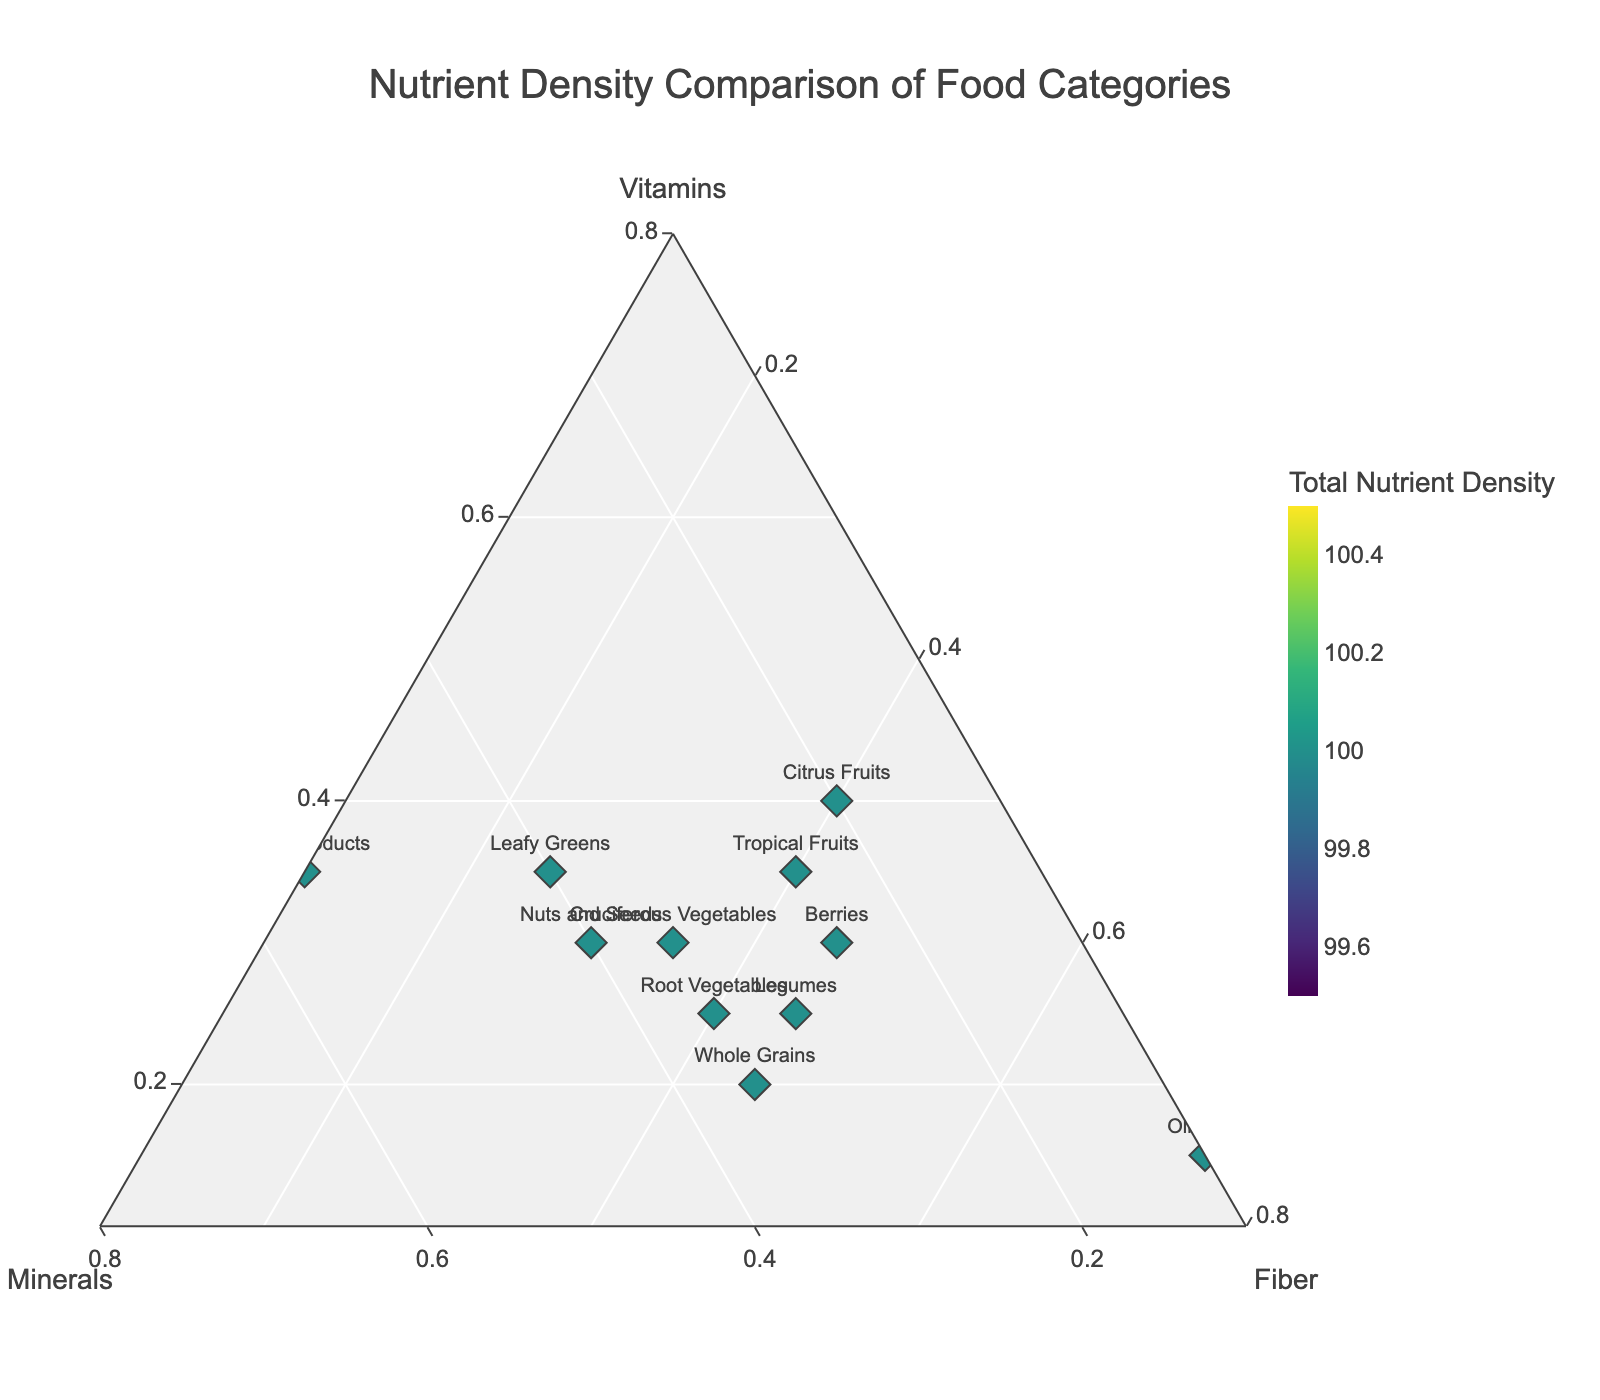How many food categories are shown in the plot? The title states the figure is a comparison of food categories, and each marker corresponds to a food category. Count the unique labels.
Answer: 14 Which food category has the highest total nutrient density? Look for the marker with the darkest color in the color scale indicating the highest value for "Total Nutrient Density".
Answer: Dairy Products What proportion of vitamins does Lean Meats have compared to its total nutrient density? Identify the marker for Lean Meats. The ternary plot shows proportions, so locate Lean Meats on the 'Vitamins' axis. Lean Meats marker falls close to 0.45 on the Vitamins axis (meaning 45%).
Answer: 45% Which food category has a balanced proportion of vitamins, minerals, and fiber? Look for markers that are roughly equidistant from the three axes, indicating similar proportions of all three nutrients.
Answer: Cruciferous Vegetables What is the difference in fiber proportion between Berries and Lean Meats? Locate Berries and Lean Meats markers on the 'Fiber' axis. Berries are at 0.45, and Lean Meats are at 0.05. Subtract their values.
Answer: 0.40 Which food has the highest proportion of fiber and what is this proportion? Find the marker closest to the 'Fiber' vertex, indicating the highest proportion of fiber. Look at the label.
Answer: Olive Oil, 75% Compare the proportion of minerals between Fish and Whole Grains. Which one is higher and by how much? Locate Fish and Whole Grains markers on the 'Minerals' axis. Fish is at 0.45, and Whole Grains are at 0.35. Subtract the values.
Answer: Fish, 0.10 Which food category has a higher combined proportion of vitamins and minerals than fiber, but is not the highest in total nutrient density? Identify markers where the sum of proportions of vitamins and minerals exceeds the proportion of fiber, but the total nutrient density color isn’t at the maximum.
Answer: Lean Meats Describe the nutrient distribution for Tropical Fruits. Locate Tropical Fruits marker in the plot. It falls at approximately 35% vitamins, 25% minerals, and 40% fiber.
Answer: 35% vitamins, 25% minerals, 40% fiber 